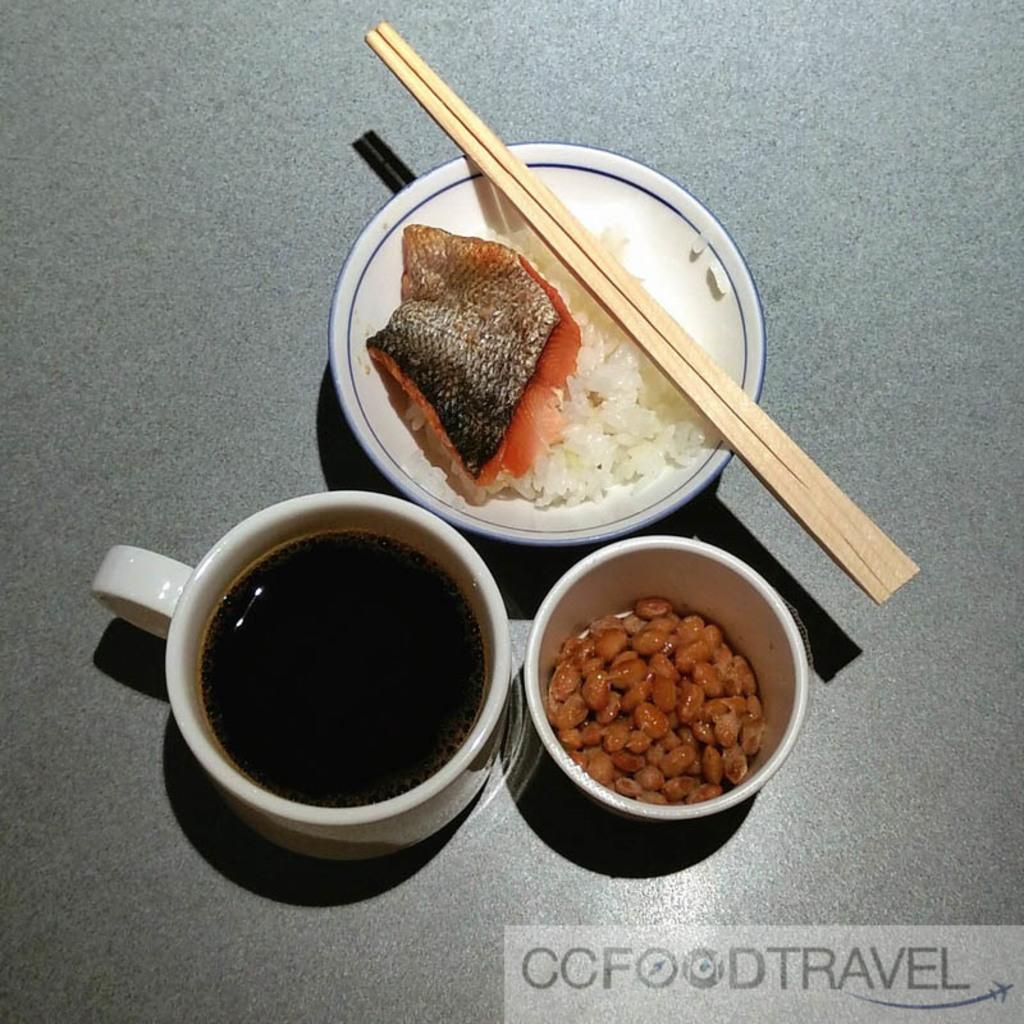What is in the cup that is visible in the image? There is a cup with liquid in the image. What is in the bowl that is visible in the image? There is a bowl with a food object in the image. What is on the plate that is visible in the image? There is a plate with fish and rice in the image. What utensil is visible in the image? There are chopsticks visible in the image. What type of suit is the woman wearing in the image? There is no woman or suit present in the image. How many friends are visible in the image? There are no friends visible in the image. 